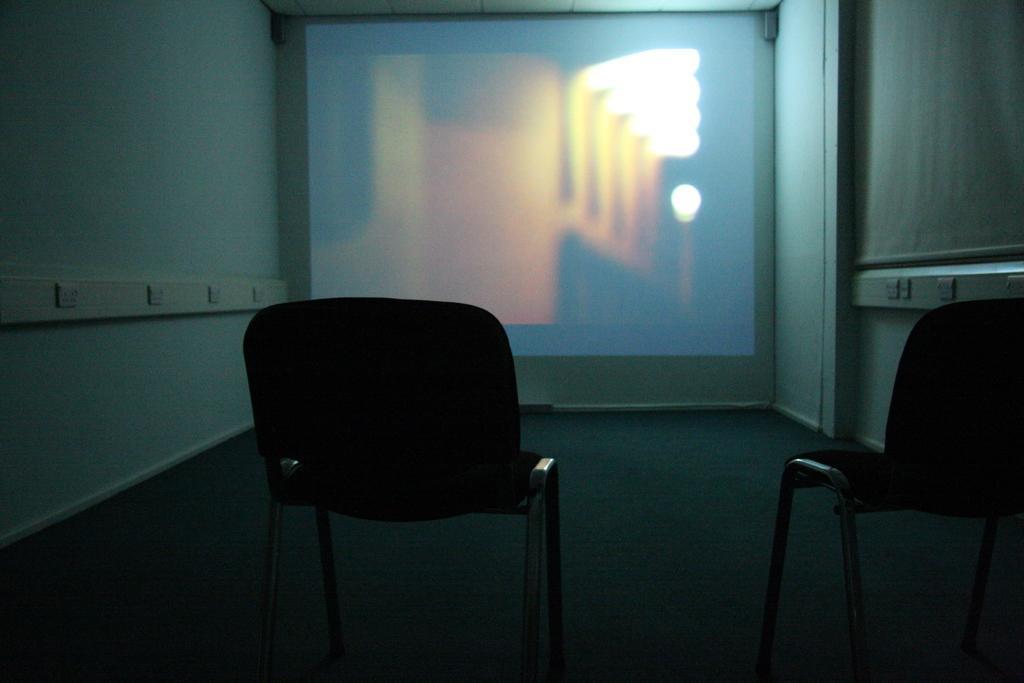How would you summarize this image in a sentence or two? In the image there are two chairs in the front, in the back there is screen on the wall with walls on the either side. 